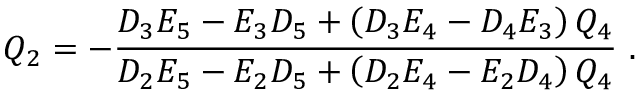<formula> <loc_0><loc_0><loc_500><loc_500>Q _ { 2 } = - \frac { D _ { 3 } E _ { 5 } - E _ { 3 } D _ { 5 } + \left ( D _ { 3 } E _ { 4 } - D _ { 4 } E _ { 3 } \right ) Q _ { 4 } } { D _ { 2 } E _ { 5 } - E _ { 2 } D _ { 5 } + \left ( D _ { 2 } E _ { 4 } - E _ { 2 } D _ { 4 } \right ) Q _ { 4 } } \ .</formula> 